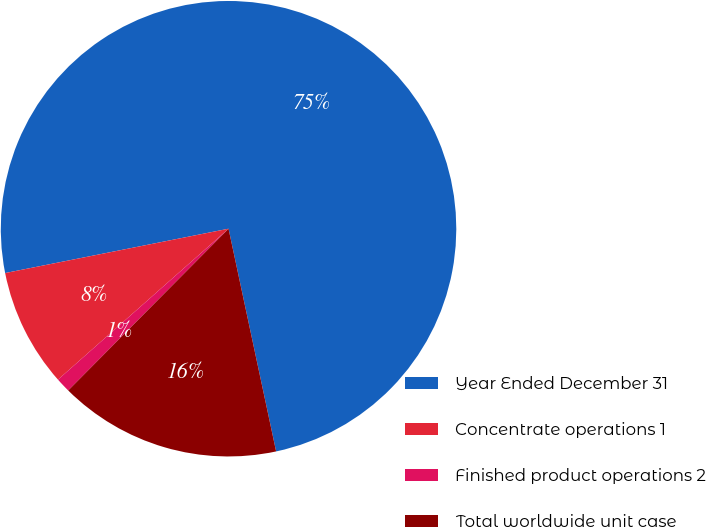Convert chart to OTSL. <chart><loc_0><loc_0><loc_500><loc_500><pie_chart><fcel>Year Ended December 31<fcel>Concentrate operations 1<fcel>Finished product operations 2<fcel>Total worldwide unit case<nl><fcel>74.76%<fcel>8.41%<fcel>1.04%<fcel>15.78%<nl></chart> 